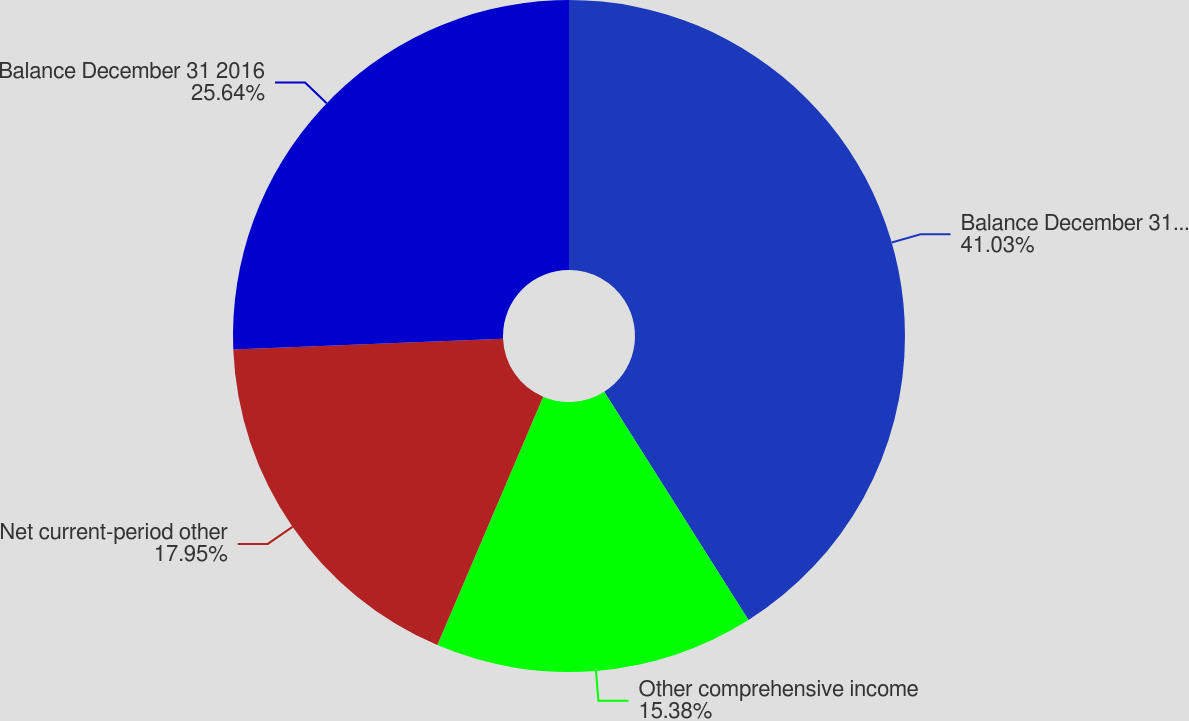<chart> <loc_0><loc_0><loc_500><loc_500><pie_chart><fcel>Balance December 31 2015<fcel>Other comprehensive income<fcel>Net current-period other<fcel>Balance December 31 2016<nl><fcel>41.03%<fcel>15.38%<fcel>17.95%<fcel>25.64%<nl></chart> 